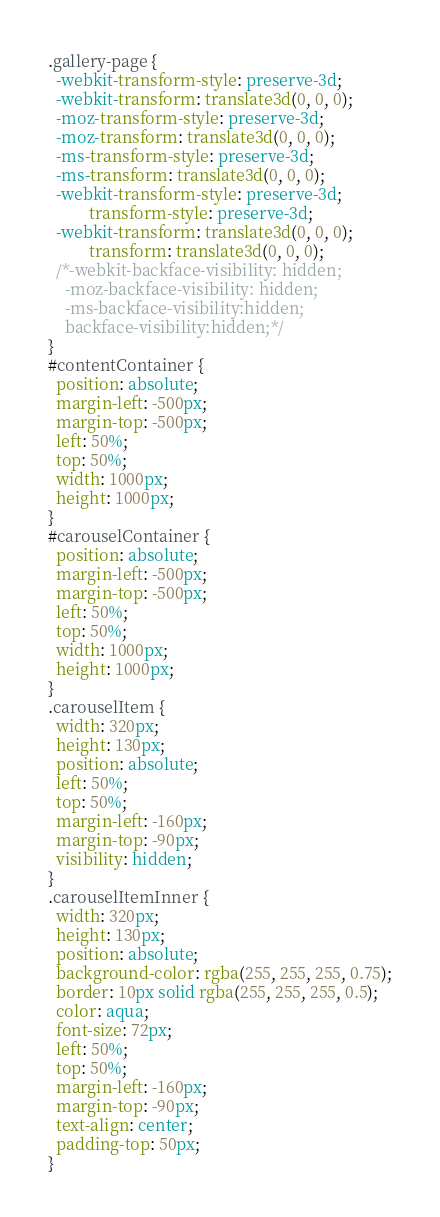Convert code to text. <code><loc_0><loc_0><loc_500><loc_500><_CSS_>.gallery-page {
  -webkit-transform-style: preserve-3d;
  -webkit-transform: translate3d(0, 0, 0);
  -moz-transform-style: preserve-3d;
  -moz-transform: translate3d(0, 0, 0);
  -ms-transform-style: preserve-3d;
  -ms-transform: translate3d(0, 0, 0);
  -webkit-transform-style: preserve-3d;
          transform-style: preserve-3d;
  -webkit-transform: translate3d(0, 0, 0);
          transform: translate3d(0, 0, 0);
  /*-webkit-backface-visibility: hidden;
	-moz-backface-visibility: hidden;
	-ms-backface-visibility:hidden;
	backface-visibility:hidden;*/
}
#contentContainer {
  position: absolute;
  margin-left: -500px;
  margin-top: -500px;
  left: 50%;
  top: 50%;
  width: 1000px;
  height: 1000px;
}
#carouselContainer {
  position: absolute;
  margin-left: -500px;
  margin-top: -500px;
  left: 50%;
  top: 50%;
  width: 1000px;
  height: 1000px;
}
.carouselItem {
  width: 320px;
  height: 130px;
  position: absolute;
  left: 50%;
  top: 50%;
  margin-left: -160px;
  margin-top: -90px;
  visibility: hidden;
}
.carouselItemInner {
  width: 320px;
  height: 130px;
  position: absolute;
  background-color: rgba(255, 255, 255, 0.75);
  border: 10px solid rgba(255, 255, 255, 0.5);
  color: aqua;
  font-size: 72px;
  left: 50%;
  top: 50%;
  margin-left: -160px;
  margin-top: -90px;
  text-align: center;
  padding-top: 50px;
}
</code> 